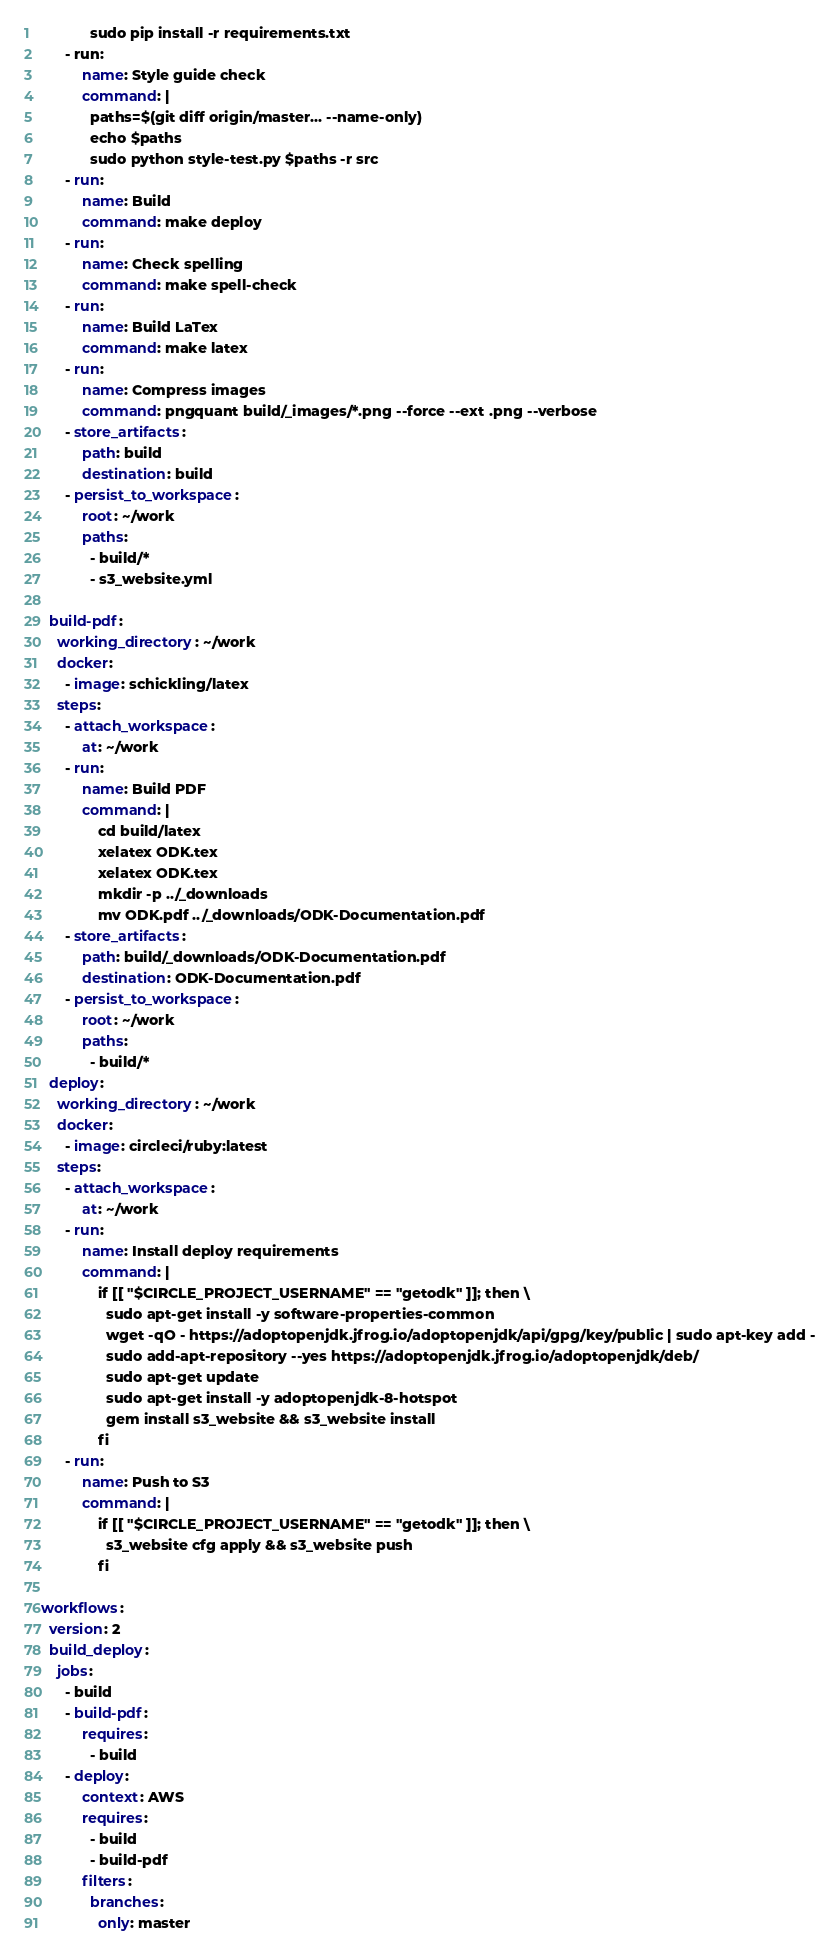Convert code to text. <code><loc_0><loc_0><loc_500><loc_500><_YAML_>            sudo pip install -r requirements.txt
      - run:
          name: Style guide check
          command: |
            paths=$(git diff origin/master... --name-only)
            echo $paths
            sudo python style-test.py $paths -r src
      - run:
          name: Build
          command: make deploy
      - run:
          name: Check spelling
          command: make spell-check
      - run:
          name: Build LaTex
          command: make latex
      - run:
          name: Compress images
          command: pngquant build/_images/*.png --force --ext .png --verbose
      - store_artifacts:
          path: build
          destination: build
      - persist_to_workspace:
          root: ~/work
          paths:
            - build/*
            - s3_website.yml

  build-pdf:
    working_directory: ~/work
    docker:
      - image: schickling/latex
    steps:
      - attach_workspace:
          at: ~/work
      - run:
          name: Build PDF
          command: |
              cd build/latex
              xelatex ODK.tex
              xelatex ODK.tex
              mkdir -p ../_downloads
              mv ODK.pdf ../_downloads/ODK-Documentation.pdf
      - store_artifacts:
          path: build/_downloads/ODK-Documentation.pdf
          destination: ODK-Documentation.pdf
      - persist_to_workspace:
          root: ~/work
          paths:
            - build/*
  deploy:
    working_directory: ~/work
    docker:
      - image: circleci/ruby:latest
    steps:
      - attach_workspace:
          at: ~/work
      - run:
          name: Install deploy requirements
          command: |
              if [[ "$CIRCLE_PROJECT_USERNAME" == "getodk" ]]; then \
                sudo apt-get install -y software-properties-common
                wget -qO - https://adoptopenjdk.jfrog.io/adoptopenjdk/api/gpg/key/public | sudo apt-key add -
                sudo add-apt-repository --yes https://adoptopenjdk.jfrog.io/adoptopenjdk/deb/
                sudo apt-get update
                sudo apt-get install -y adoptopenjdk-8-hotspot
                gem install s3_website && s3_website install
              fi
      - run:
          name: Push to S3
          command: |
              if [[ "$CIRCLE_PROJECT_USERNAME" == "getodk" ]]; then \
                s3_website cfg apply && s3_website push
              fi

workflows:
  version: 2
  build_deploy:
    jobs:
      - build
      - build-pdf:
          requires:
            - build
      - deploy:
          context: AWS
          requires:
            - build
            - build-pdf
          filters:
            branches:
              only: master
</code> 